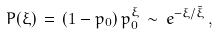Convert formula to latex. <formula><loc_0><loc_0><loc_500><loc_500>P ( \xi ) \, = \, ( 1 - p _ { 0 } ) \, p _ { 0 } ^ { \xi } \, \sim \, e ^ { - \xi / \bar { \xi } } \, ,</formula> 